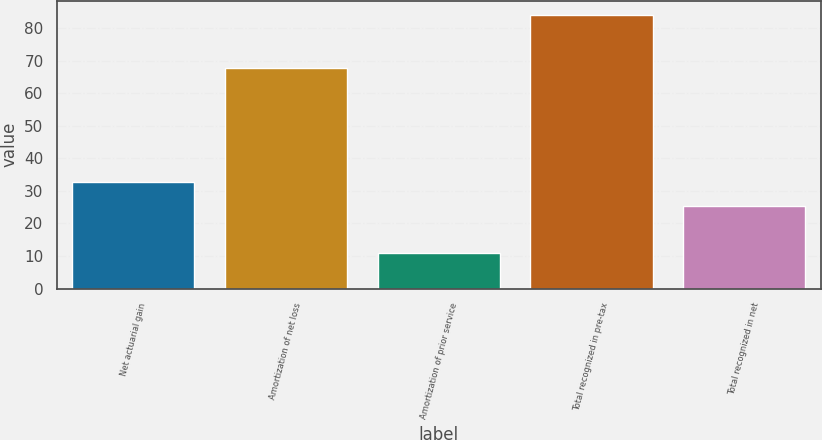Convert chart. <chart><loc_0><loc_0><loc_500><loc_500><bar_chart><fcel>Net actuarial gain<fcel>Amortization of net loss<fcel>Amortization of prior service<fcel>Total recognized in pre-tax<fcel>Total recognized in net<nl><fcel>32.71<fcel>67.6<fcel>11<fcel>84.1<fcel>25.4<nl></chart> 